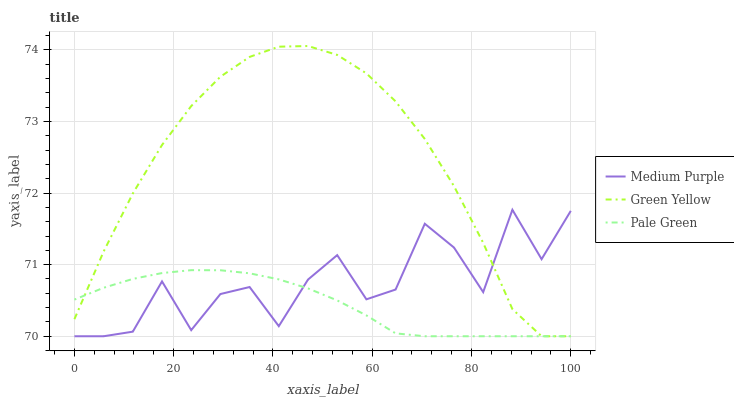Does Pale Green have the minimum area under the curve?
Answer yes or no. Yes. Does Green Yellow have the minimum area under the curve?
Answer yes or no. No. Does Pale Green have the maximum area under the curve?
Answer yes or no. No. Is Medium Purple the roughest?
Answer yes or no. Yes. Is Green Yellow the smoothest?
Answer yes or no. No. Is Green Yellow the roughest?
Answer yes or no. No. Does Pale Green have the highest value?
Answer yes or no. No. 